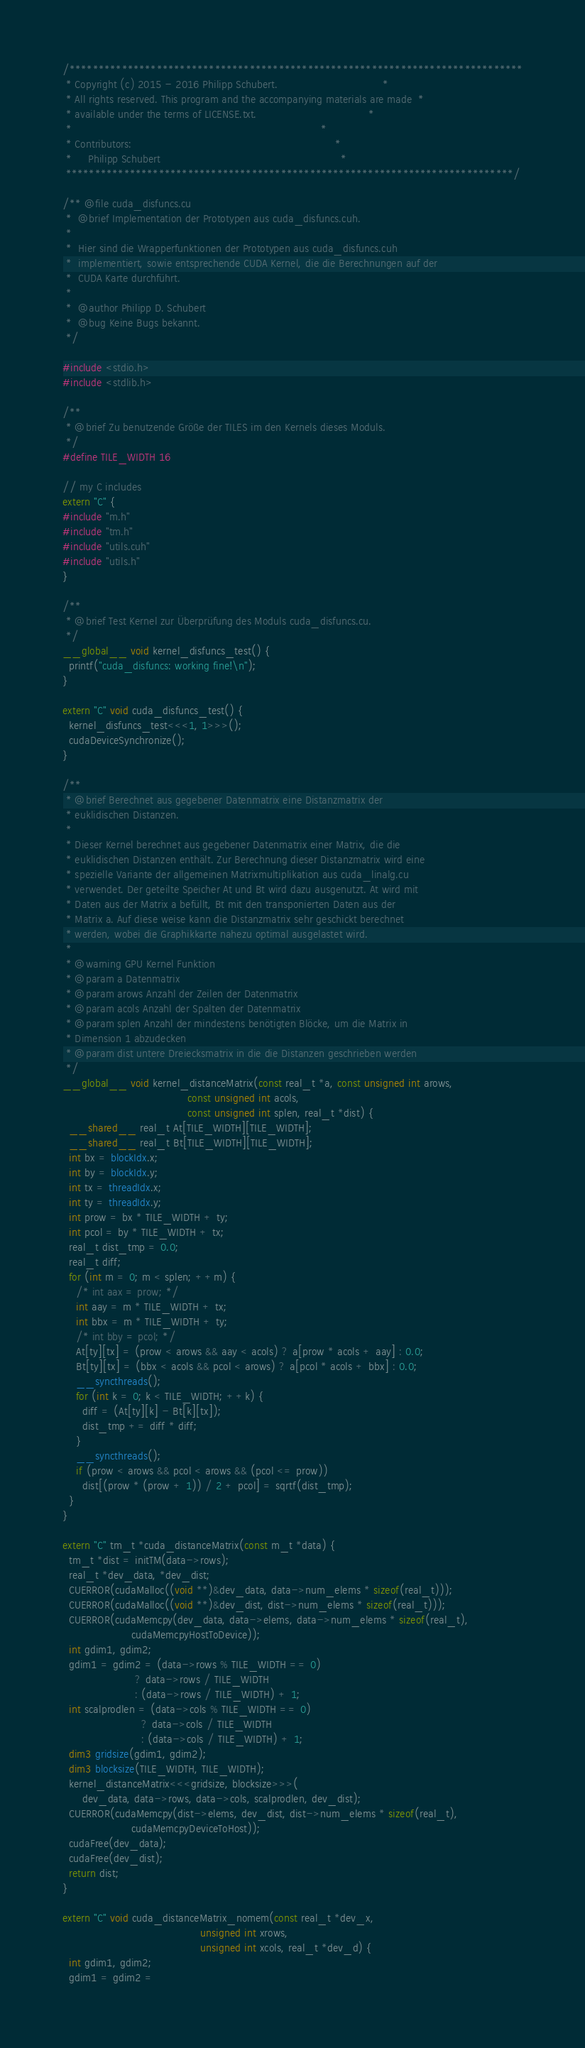<code> <loc_0><loc_0><loc_500><loc_500><_Cuda_>/******************************************************************************
 * Copyright (c) 2015 - 2016 Philipp Schubert.                                *
 * All rights reserved. This program and the accompanying materials are made  *
 * available under the terms of LICENSE.txt.                                  *
 *                                                                            *
 * Contributors:                                                              *
 *     Philipp Schubert                                                       *
 *****************************************************************************/

/** @file cuda_disfuncs.cu
 *  @brief Implementation der Prototypen aus cuda_disfuncs.cuh.
 *
 *  Hier sind die Wrapperfunktionen der Prototypen aus cuda_disfuncs.cuh
 *  implementiert, sowie entsprechende CUDA Kernel, die die Berechnungen auf der
 *  CUDA Karte durchführt.
 *
 *  @author Philipp D. Schubert
 *  @bug Keine Bugs bekannt.
 */

#include <stdio.h>
#include <stdlib.h>

/**
 * @brief Zu benutzende Größe der TILES im den Kernels dieses Moduls.
 */
#define TILE_WIDTH 16

// my C includes
extern "C" {
#include "m.h"
#include "tm.h"
#include "utils.cuh"
#include "utils.h"
}

/**
 * @brief Test Kernel zur Überprüfung des Moduls cuda_disfuncs.cu.
 */
__global__ void kernel_disfuncs_test() {
  printf("cuda_disfuncs: working fine!\n");
}

extern "C" void cuda_disfuncs_test() {
  kernel_disfuncs_test<<<1, 1>>>();
  cudaDeviceSynchronize();
}

/**
 * @brief Berechnet aus gegebener Datenmatrix eine Distanzmatrix der
 * euklidischen Distanzen.
 *
 * Dieser Kernel berechnet aus gegebener Datenmatrix einer Matrix, die die
 * euklidischen Distanzen enthält. Zur Berechnung dieser Distanzmatrix wird eine
 * spezielle Variante der allgemeinen Matrixmultiplikation aus cuda_linalg.cu
 * verwendet. Der geteilte Speicher At und Bt wird dazu ausgenutzt. At wird mit
 * Daten aus der Matrix a befüllt, Bt mit den transponierten Daten aus der
 * Matrix a. Auf diese weise kann die Distanzmatrix sehr geschickt berechnet
 * werden, wobei die Graphikkarte nahezu optimal ausgelastet wird.
 *
 * @warning GPU Kernel Funktion
 * @param a Datenmatrix
 * @param arows Anzahl der Zeilen der Datenmatrix
 * @param acols Anzahl der Spalten der Datenmatrix
 * @param splen Anzahl der mindestens benötigten Blöcke, um die Matrix in
 * Dimension 1 abzudecken
 * @param dist untere Dreiecksmatrix in die die Distanzen geschrieben werden
 */
__global__ void kernel_distanceMatrix(const real_t *a, const unsigned int arows,
                                      const unsigned int acols,
                                      const unsigned int splen, real_t *dist) {
  __shared__ real_t At[TILE_WIDTH][TILE_WIDTH];
  __shared__ real_t Bt[TILE_WIDTH][TILE_WIDTH];
  int bx = blockIdx.x;
  int by = blockIdx.y;
  int tx = threadIdx.x;
  int ty = threadIdx.y;
  int prow = bx * TILE_WIDTH + ty;
  int pcol = by * TILE_WIDTH + tx;
  real_t dist_tmp = 0.0;
  real_t diff;
  for (int m = 0; m < splen; ++m) {
    /* int aax = prow; */
    int aay = m * TILE_WIDTH + tx;
    int bbx = m * TILE_WIDTH + ty;
    /* int bby = pcol; */
    At[ty][tx] = (prow < arows && aay < acols) ? a[prow * acols + aay] : 0.0;
    Bt[ty][tx] = (bbx < acols && pcol < arows) ? a[pcol * acols + bbx] : 0.0;
    __syncthreads();
    for (int k = 0; k < TILE_WIDTH; ++k) {
      diff = (At[ty][k] - Bt[k][tx]);
      dist_tmp += diff * diff;
    }
    __syncthreads();
    if (prow < arows && pcol < arows && (pcol <= prow))
      dist[(prow * (prow + 1)) / 2 + pcol] = sqrtf(dist_tmp);
  }
}

extern "C" tm_t *cuda_distanceMatrix(const m_t *data) {
  tm_t *dist = initTM(data->rows);
  real_t *dev_data, *dev_dist;
  CUERROR(cudaMalloc((void **)&dev_data, data->num_elems * sizeof(real_t)));
  CUERROR(cudaMalloc((void **)&dev_dist, dist->num_elems * sizeof(real_t)));
  CUERROR(cudaMemcpy(dev_data, data->elems, data->num_elems * sizeof(real_t),
                     cudaMemcpyHostToDevice));
  int gdim1, gdim2;
  gdim1 = gdim2 = (data->rows % TILE_WIDTH == 0)
                      ? data->rows / TILE_WIDTH
                      : (data->rows / TILE_WIDTH) + 1;
  int scalprodlen = (data->cols % TILE_WIDTH == 0)
                        ? data->cols / TILE_WIDTH
                        : (data->cols / TILE_WIDTH) + 1;
  dim3 gridsize(gdim1, gdim2);
  dim3 blocksize(TILE_WIDTH, TILE_WIDTH);
  kernel_distanceMatrix<<<gridsize, blocksize>>>(
      dev_data, data->rows, data->cols, scalprodlen, dev_dist);
  CUERROR(cudaMemcpy(dist->elems, dev_dist, dist->num_elems * sizeof(real_t),
                     cudaMemcpyDeviceToHost));
  cudaFree(dev_data);
  cudaFree(dev_dist);
  return dist;
}

extern "C" void cuda_distanceMatrix_nomem(const real_t *dev_x,
                                          unsigned int xrows,
                                          unsigned int xcols, real_t *dev_d) {
  int gdim1, gdim2;
  gdim1 = gdim2 =</code> 